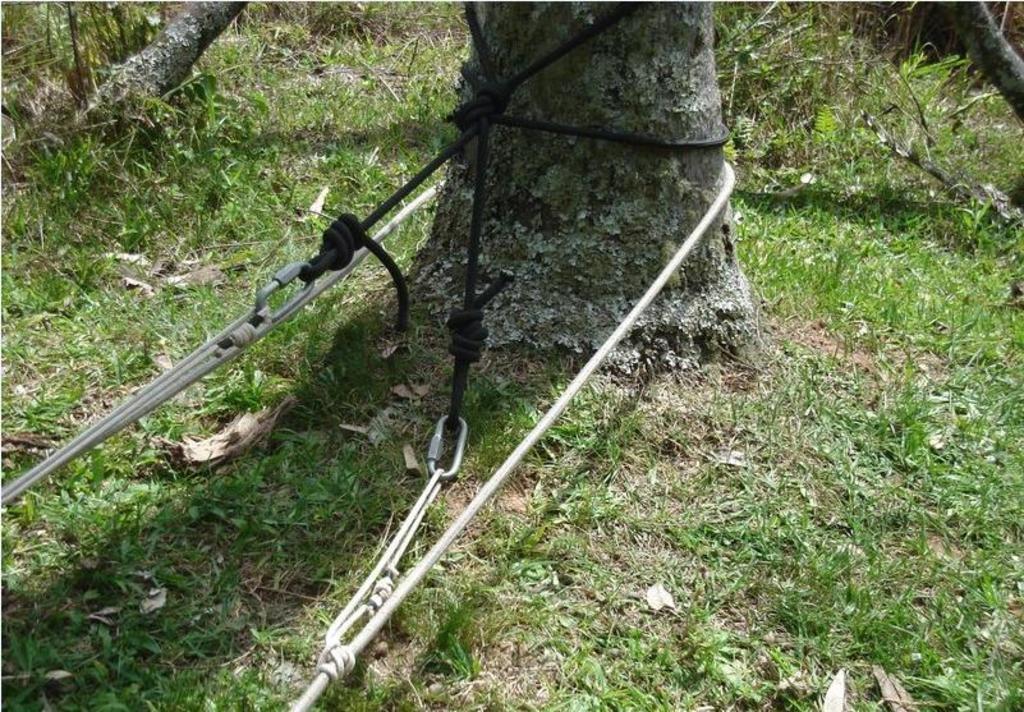In one or two sentences, can you explain what this image depicts? In this image we can see ropes tied to the tree and we can see sticks, plants and grass on the ground. 